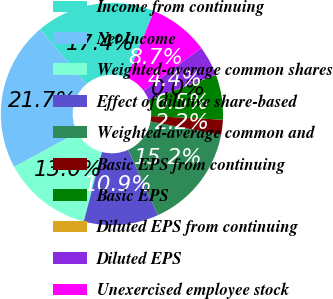<chart> <loc_0><loc_0><loc_500><loc_500><pie_chart><fcel>Income from continuing<fcel>Net Income<fcel>Weighted-average common shares<fcel>Effect of dilutive share-based<fcel>Weighted-average common and<fcel>Basic EPS from continuing<fcel>Basic EPS<fcel>Diluted EPS from continuing<fcel>Diluted EPS<fcel>Unexercised employee stock<nl><fcel>17.37%<fcel>21.7%<fcel>13.03%<fcel>10.87%<fcel>15.2%<fcel>2.2%<fcel>6.53%<fcel>0.04%<fcel>4.37%<fcel>8.7%<nl></chart> 